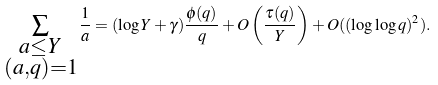<formula> <loc_0><loc_0><loc_500><loc_500>\sum _ { \substack { a \leq Y \\ ( a , q ) = 1 } } \frac { 1 } { a } = ( \log Y + \gamma ) \frac { \phi ( q ) } { q } + O \left ( \frac { \tau ( q ) } { Y } \right ) + O ( ( \log \log q ) ^ { 2 } ) .</formula> 